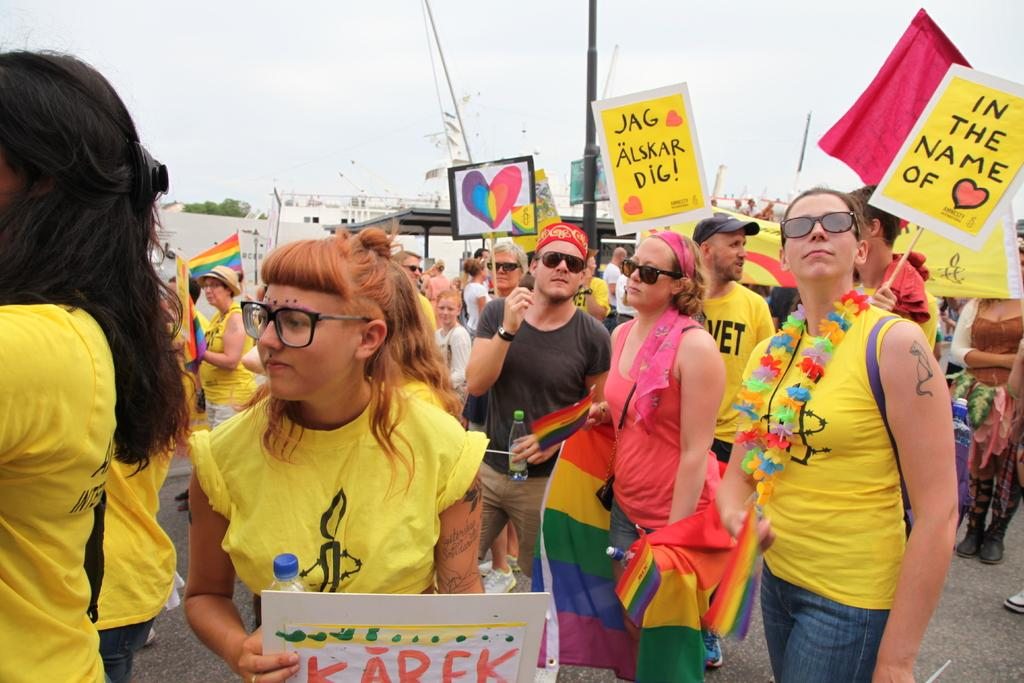What are the people in the image doing? The people in the image are standing on the road. What are the people holding in the image? The people are holding placards. What can be seen in the background of the image? There are buildings and trees in the background. What type of hope can be seen in the image? There is no specific type of hope present in the image; it features people standing on the road with placards. 